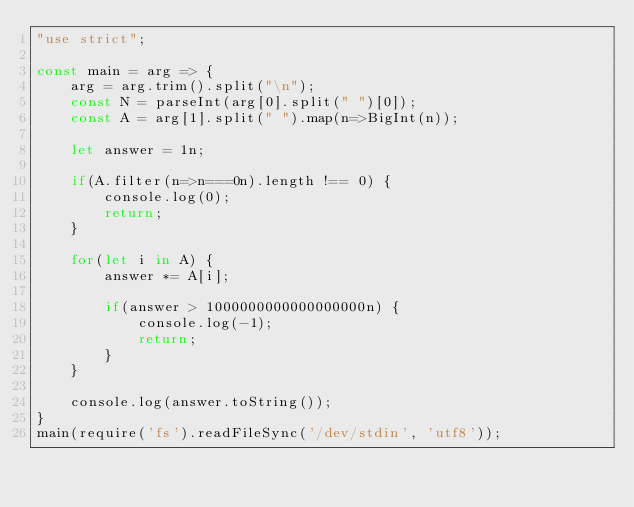Convert code to text. <code><loc_0><loc_0><loc_500><loc_500><_JavaScript_>"use strict";
    
const main = arg => {
    arg = arg.trim().split("\n");
    const N = parseInt(arg[0].split(" ")[0]);
    const A = arg[1].split(" ").map(n=>BigInt(n));
    
    let answer = 1n;

    if(A.filter(n=>n===0n).length !== 0) {
        console.log(0);
        return;
    }
    
    for(let i in A) {
        answer *= A[i];
        
        if(answer > 1000000000000000000n) {
            console.log(-1);
            return;
        }
    }
    
    console.log(answer.toString());
}
main(require('fs').readFileSync('/dev/stdin', 'utf8'));</code> 